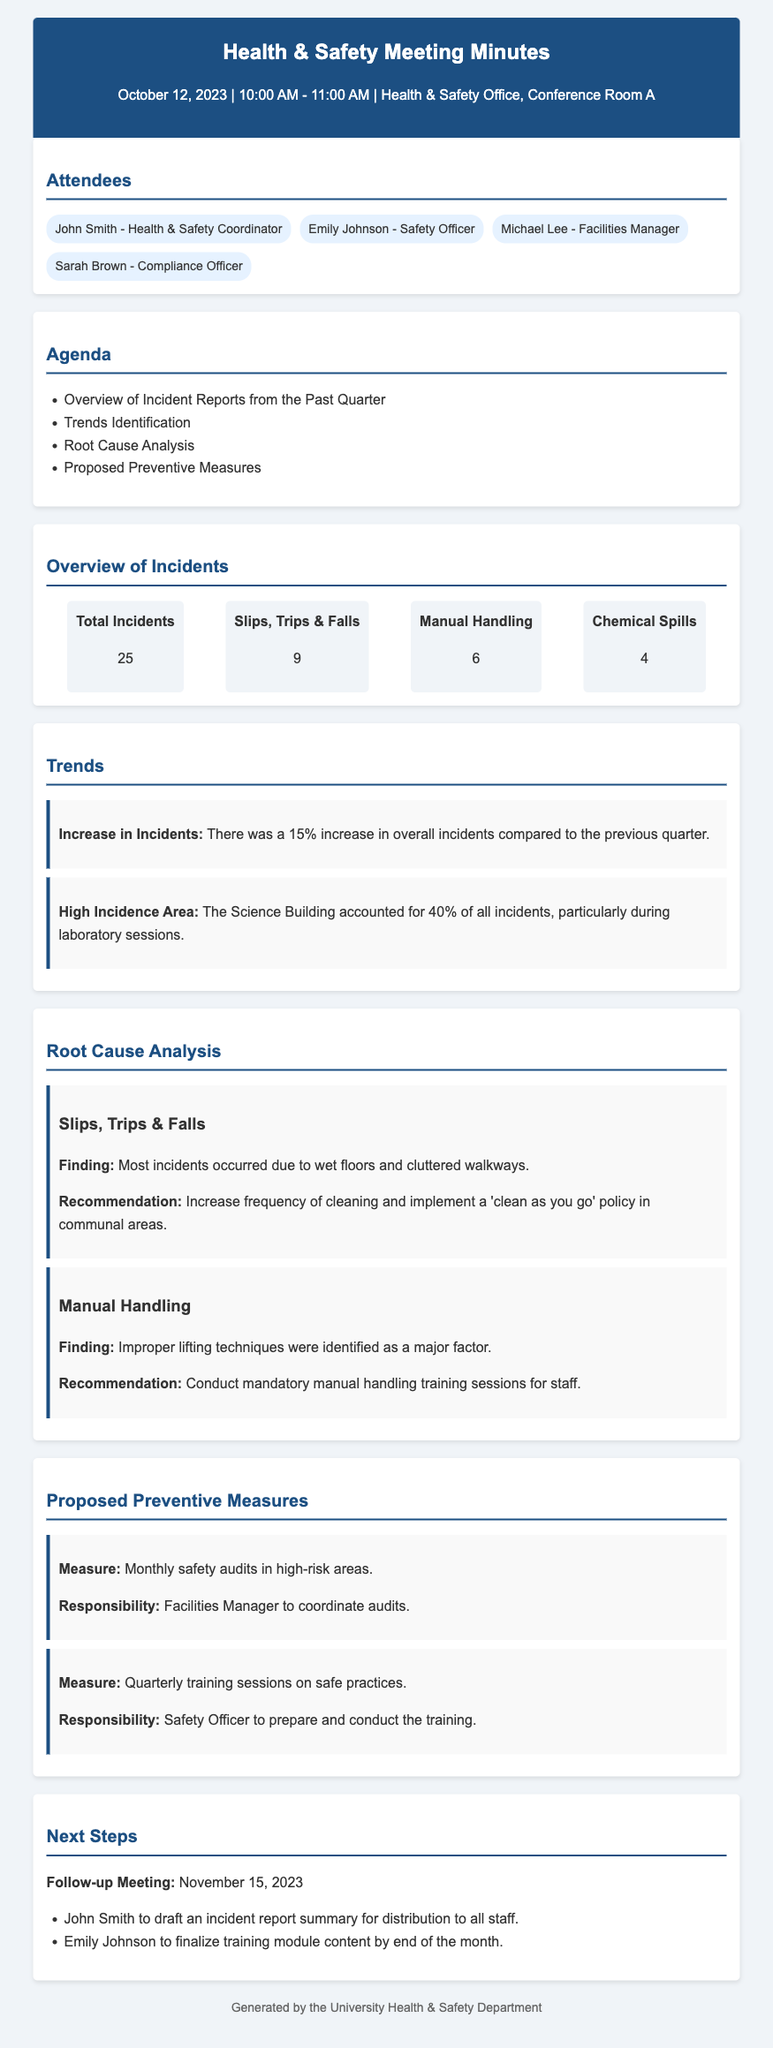What is the total number of incidents reported? The total number of incidents is indicated by the "Total Incidents" section which states there were 25 incidents reported.
Answer: 25 Which type of incidents had the highest count? The incidents with the highest count is noted as "Slips, Trips & Falls" which account for 9 of the total incidents.
Answer: Slips, Trips & Falls What percentage of incidents occurred in the Science Building? The document mentions that the Science Building accounted for 40% of all incidents, allowing us to identify that specific percentage.
Answer: 40% What finding was identified for slips, trips, and falls? The finding is specified in the "Root Cause Analysis" section where wet floors and cluttered walkways were cited as major causes for these incidents.
Answer: Wet floors and cluttered walkways Who is responsible for coordinating the monthly safety audits? The responsibilities for coordinating audits are mentioned, identifying that the Facilities Manager is tasked with this duty.
Answer: Facilities Manager What is the increase in incidents compared to the previous quarter? The document states that there was a 15% increase in overall incidents when compared to data from the previous quarter.
Answer: 15% What type of training sessions are suggested as a preventive measure? The proposed preventive measures include "Quarterly training sessions on safe practices" as a means to address safety concerns.
Answer: Quarterly training sessions on safe practices When is the follow-up meeting scheduled? The follow-up meeting date is specifically stated in the "Next Steps" section where it notes that it will take place on November 15, 2023.
Answer: November 15, 2023 What recommendation was made regarding manual handling? The document specifies that it is recommended to conduct mandatory manual handling training sessions for staff to address related issues.
Answer: Conduct mandatory manual handling training sessions for staff 